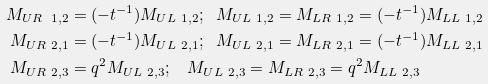<formula> <loc_0><loc_0><loc_500><loc_500>M _ { U R \ 1 , 2 } & = ( - t ^ { - 1 } ) M _ { U L \ 1 , 2 } ; \ \ M _ { U L \ 1 , 2 } = M _ { L R \ 1 , 2 } = ( - t ^ { - 1 } ) M _ { L L \ 1 , 2 } \\ M _ { U R \ 2 , 1 } & = ( - t ^ { - 1 } ) M _ { U L \ 2 , 1 } ; \ \ M _ { U L \ 2 , 1 } = M _ { L R \ 2 , 1 } = ( - t ^ { - 1 } ) M _ { L L \ 2 , 1 } \\ M _ { U R \ 2 , 3 } & = q ^ { 2 } M _ { U L \ 2 , 3 } ; \quad M _ { U L \ 2 , 3 } = M _ { L R \ 2 , 3 } = q ^ { 2 } M _ { L L \ 2 , 3 }</formula> 